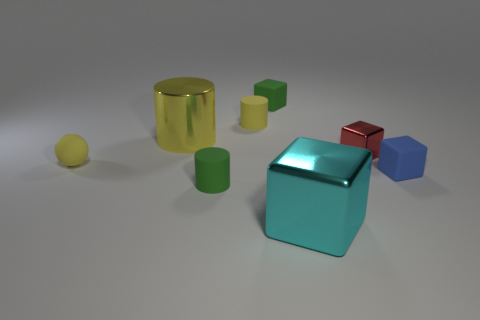Could you explain the lighting setup in this scene? Certainly! The scene is lit from above, as evident from the soft shadows directly beneath the objects, suggesting a single diffused light source, like a softbox. This gives the image a calm and even ambience. How does the lighting affect the colors of the objects? The diffuse light helps bring out the true colors of the objects, minimizing harsh reflections and shadows. It allows the objects' colors to appear more vivid and makes the metallic objects shine without overwhelming glare. 